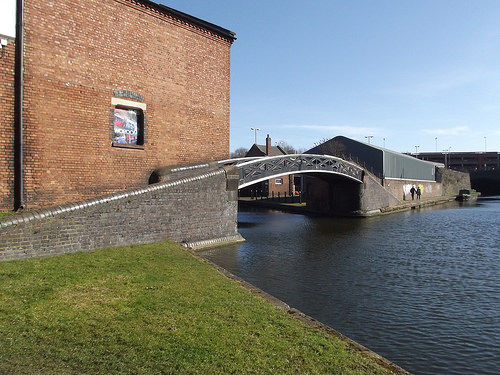<image>
Is there a people next to the bridge? Yes. The people is positioned adjacent to the bridge, located nearby in the same general area. 